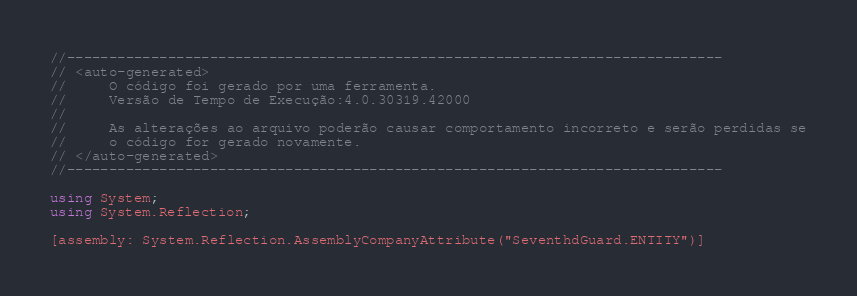<code> <loc_0><loc_0><loc_500><loc_500><_C#_>//------------------------------------------------------------------------------
// <auto-generated>
//     O código foi gerado por uma ferramenta.
//     Versão de Tempo de Execução:4.0.30319.42000
//
//     As alterações ao arquivo poderão causar comportamento incorreto e serão perdidas se
//     o código for gerado novamente.
// </auto-generated>
//------------------------------------------------------------------------------

using System;
using System.Reflection;

[assembly: System.Reflection.AssemblyCompanyAttribute("SeventhdGuard.ENTITY")]</code> 